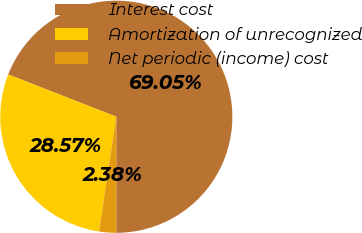Convert chart. <chart><loc_0><loc_0><loc_500><loc_500><pie_chart><fcel>Interest cost<fcel>Amortization of unrecognized<fcel>Net periodic (income) cost<nl><fcel>69.05%<fcel>28.57%<fcel>2.38%<nl></chart> 